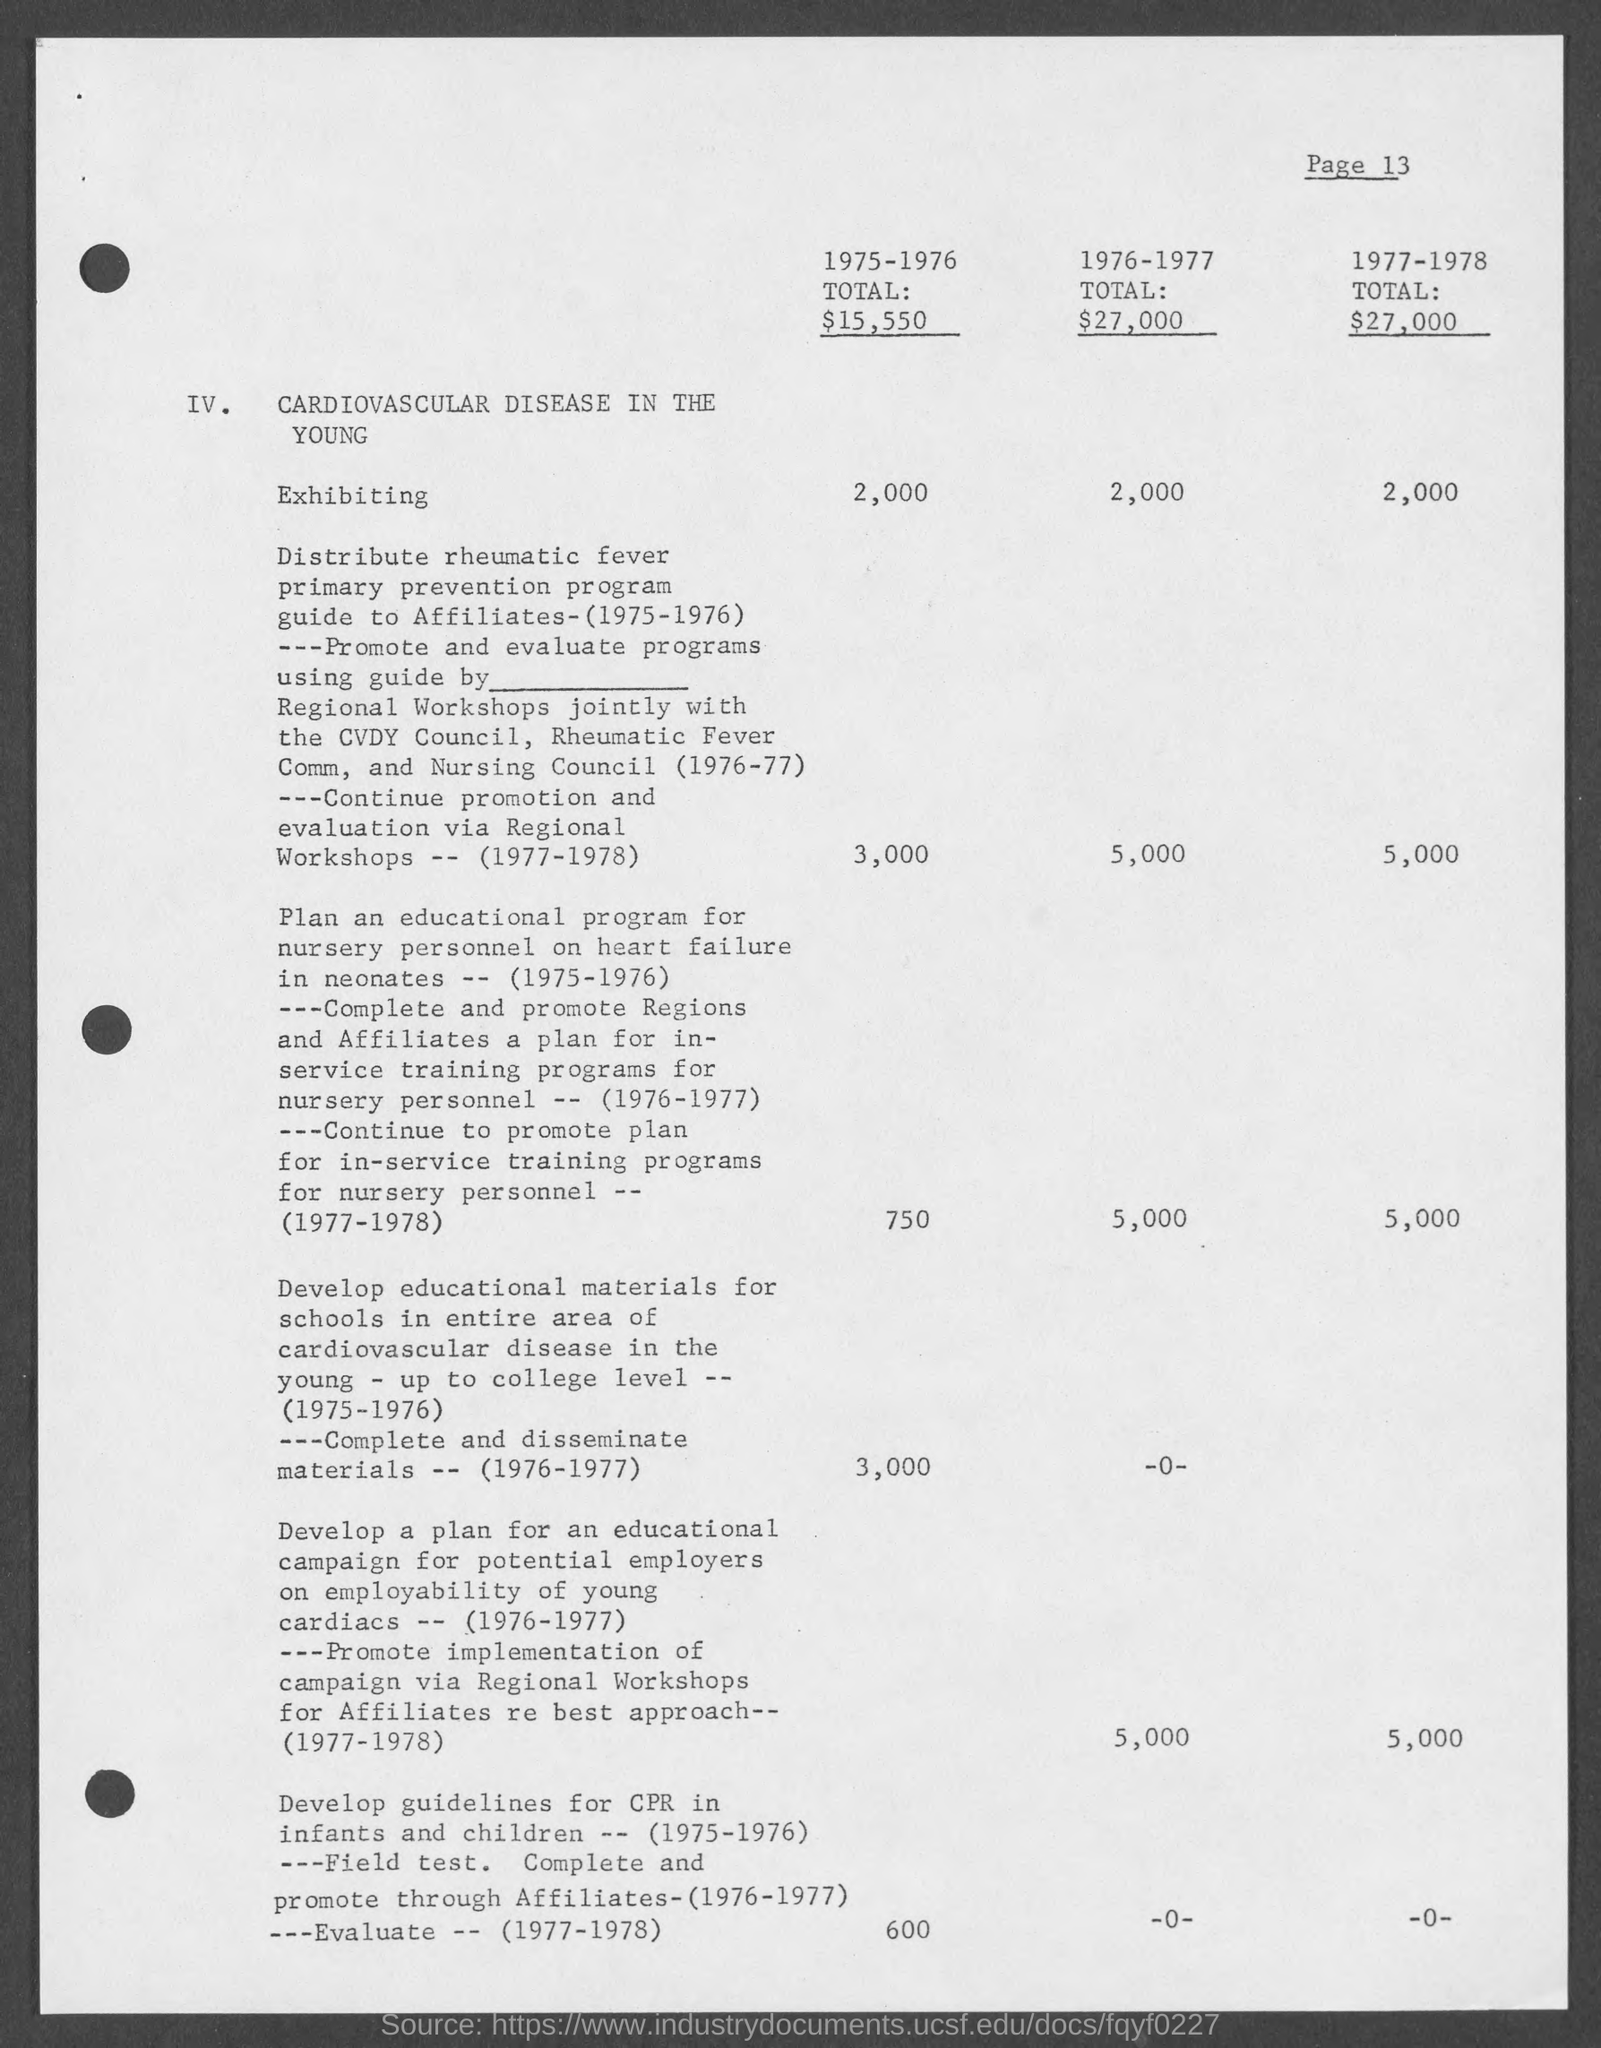What is the page number on this document?
Keep it short and to the point. Page 13. What is the total from 1975-1976?
Make the answer very short. $15,550. 